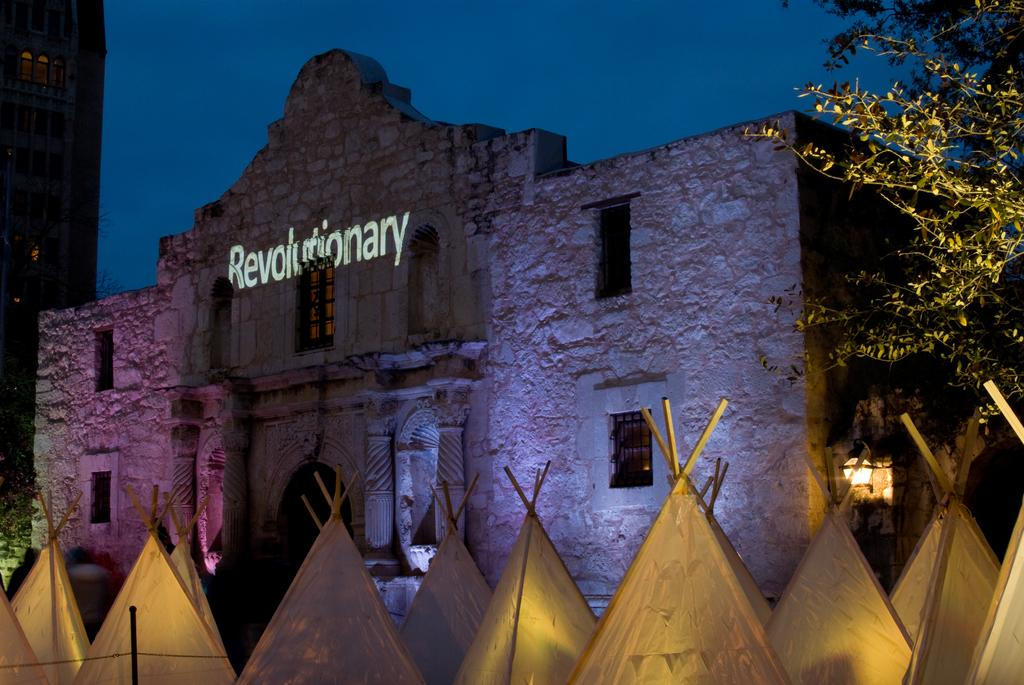<image>
Give a short and clear explanation of the subsequent image. An old brick building replica of the Alamo is lit up with the word Revolutionary on it. 